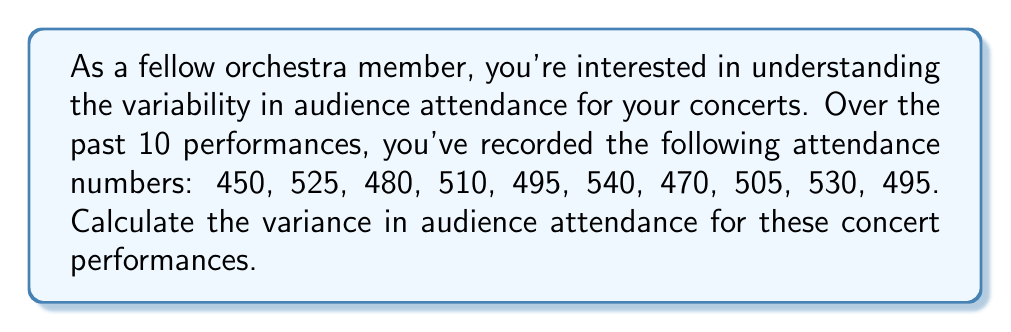Can you answer this question? To find the variance, we'll follow these steps:

1) First, calculate the mean attendance:
   $$\mu = \frac{450 + 525 + 480 + 510 + 495 + 540 + 470 + 505 + 530 + 495}{10} = 500$$

2) Next, calculate the squared differences from the mean:
   $$(450 - 500)^2 = (-50)^2 = 2500$$
   $$(525 - 500)^2 = (25)^2 = 625$$
   $$(480 - 500)^2 = (-20)^2 = 400$$
   $$(510 - 500)^2 = (10)^2 = 100$$
   $$(495 - 500)^2 = (-5)^2 = 25$$
   $$(540 - 500)^2 = (40)^2 = 1600$$
   $$(470 - 500)^2 = (-30)^2 = 900$$
   $$(505 - 500)^2 = (5)^2 = 25$$
   $$(530 - 500)^2 = (30)^2 = 900$$
   $$(495 - 500)^2 = (-5)^2 = 25$$

3) Sum these squared differences:
   $$2500 + 625 + 400 + 100 + 25 + 1600 + 900 + 25 + 900 + 25 = 7100$$

4) Divide by the number of performances (10) to get the variance:
   $$\text{Variance} = \frac{7100}{10} = 710$$

Therefore, the variance in audience attendance is 710.
Answer: 710 